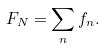Convert formula to latex. <formula><loc_0><loc_0><loc_500><loc_500>F _ { N } = \sum _ { n } f _ { n } .</formula> 